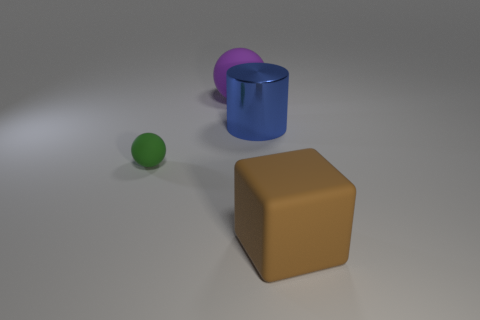Add 1 blue metal cylinders. How many objects exist? 5 Subtract all purple spheres. How many spheres are left? 1 Subtract all cylinders. How many objects are left? 3 Add 3 small objects. How many small objects exist? 4 Subtract 0 purple cylinders. How many objects are left? 4 Subtract all yellow cubes. Subtract all red cylinders. How many cubes are left? 1 Subtract all big metal cylinders. Subtract all metallic cylinders. How many objects are left? 2 Add 4 tiny green spheres. How many tiny green spheres are left? 5 